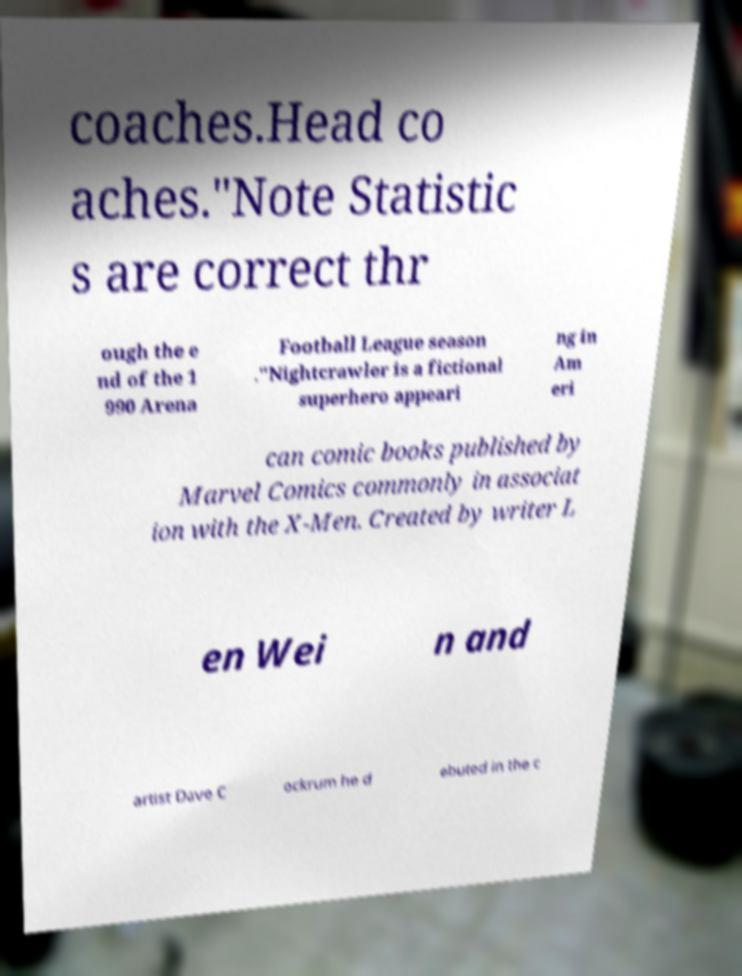Please read and relay the text visible in this image. What does it say? coaches.Head co aches."Note Statistic s are correct thr ough the e nd of the 1 990 Arena Football League season ."Nightcrawler is a fictional superhero appeari ng in Am eri can comic books published by Marvel Comics commonly in associat ion with the X-Men. Created by writer L en Wei n and artist Dave C ockrum he d ebuted in the c 